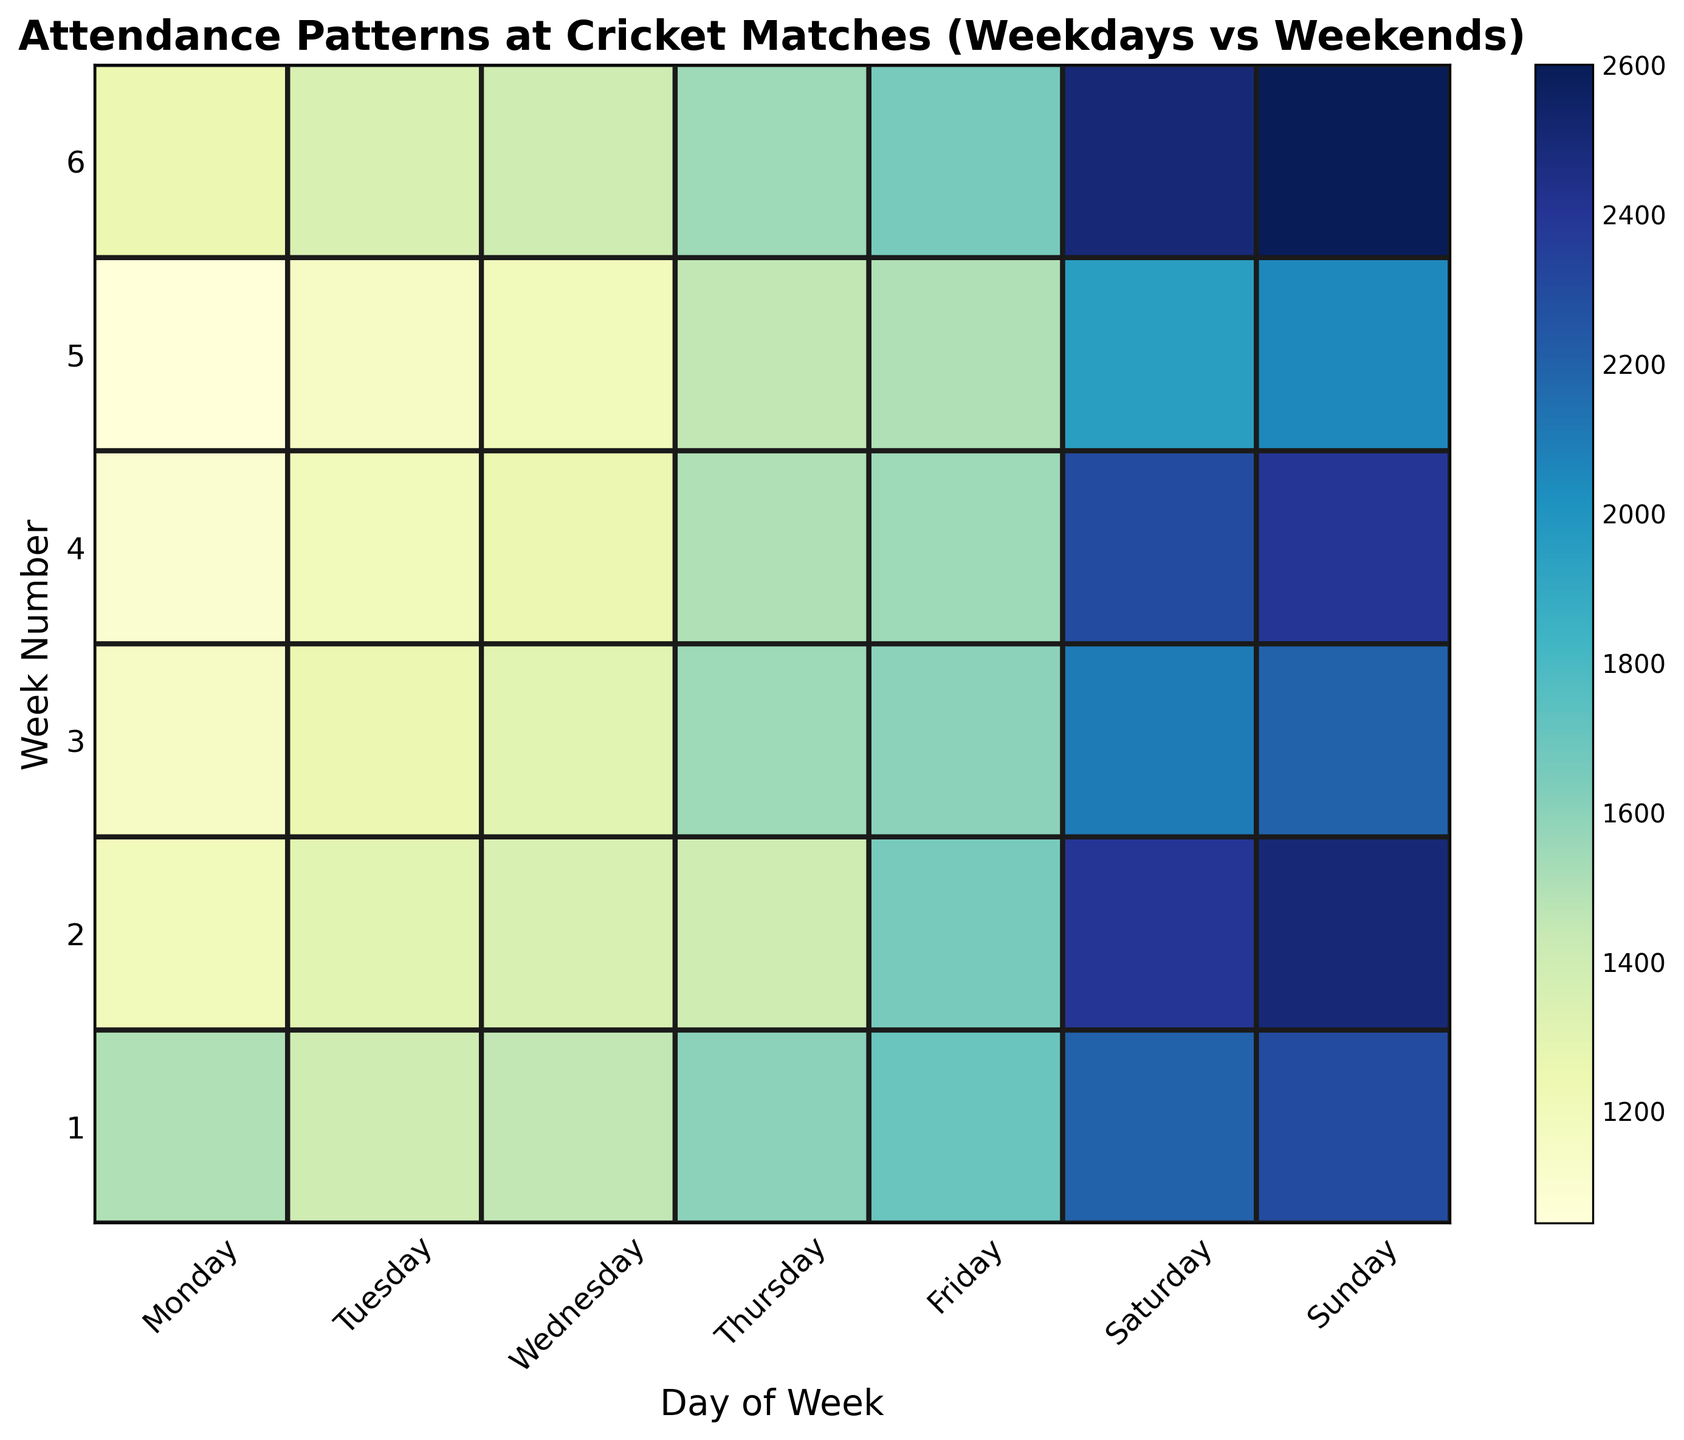Which day has the highest attendance overall? To find the day with the highest attendance, look for the darkest color in the heatmap. The darkest color represents the highest values. The darkest cells are under the "Sunday" column.
Answer: Sunday What is the average attendance on weekends? Calculate the average attendance for Saturday and Sunday across all weeks. Add up the attendance for all Saturdays and Sundays, then divide by the number of Saturdays and Sundays.
Answer: 2292.86 Which weekday shows the lowest attendance on average? Examine the cells corresponding to each weekday and identify the column with the lightest average colors. The "Monday" column consistently has lighter colors.
Answer: Monday Is there a significant difference between weekend and weekday attendance? Compare the colors of the weekend days (Saturday and Sunday) to the colors of the weekdays (Monday to Friday). Weekends consistently have darker colors, indicating higher attendance.
Answer: Yes Which week recorded the highest attendance on a Sunday? Identify the darkest cell in the "Sunday" column and note its corresponding week number. The darkest cell appears in Week 6.
Answer: Week 6 On which day is the attendance generally increasing towards the weekend? Trace the gradient of colors from Monday to Sunday and observe the general trend. The colors get progressively darker from Monday through to Sunday.
Answer: Sunday What is the attendance difference between the highest attended Sunday and the lowest attended Tuesday? Find the highest attendance value on Sundays and the lowest on Tuesdays. Subtract the Tuesday value from the Sunday value. Highest Sunday attendance is 2600, and the lowest Tuesday attendance is 1150.
Answer: 1450 During which week did Tuesday have more attendance than Wednesday? Look at the columns for Tuesday and Wednesday and identify weeks where Tuesday's cells are darker than Wednesday’s cells. In Week 2, Tuesday has 1350, and Wednesday has 1300.
Answer: Week 2 What is the trend in attendance as the week progresses? Observe the change in colors from Monday to Sunday. The colors start from lighter shades and progressively turn darker towards the end of the week.
Answer: Increasing Which week has the lowest overall attendance? Find the week with the lightest overall color distribution across all days. Week 5 appears the lightest overall.
Answer: Week 5 